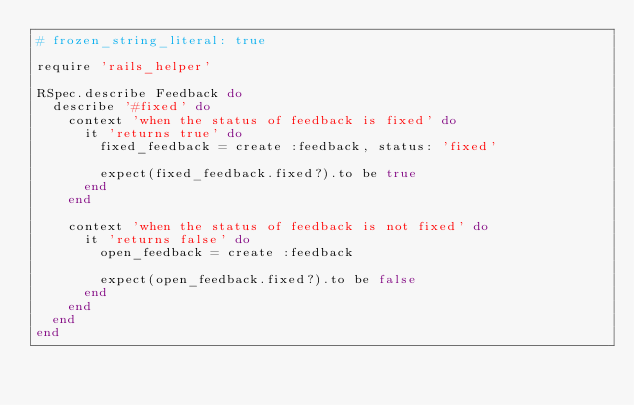<code> <loc_0><loc_0><loc_500><loc_500><_Ruby_># frozen_string_literal: true

require 'rails_helper'

RSpec.describe Feedback do
  describe '#fixed' do
    context 'when the status of feedback is fixed' do
      it 'returns true' do
        fixed_feedback = create :feedback, status: 'fixed'

        expect(fixed_feedback.fixed?).to be true
      end
    end

    context 'when the status of feedback is not fixed' do
      it 'returns false' do
        open_feedback = create :feedback

        expect(open_feedback.fixed?).to be false
      end
    end
  end
end
</code> 